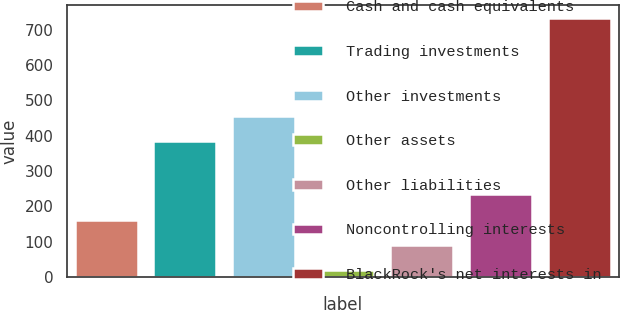Convert chart. <chart><loc_0><loc_0><loc_500><loc_500><bar_chart><fcel>Cash and cash equivalents<fcel>Trading investments<fcel>Other investments<fcel>Other assets<fcel>Other liabilities<fcel>Noncontrolling interests<fcel>BlackRock's net interests in<nl><fcel>162.4<fcel>385<fcel>456.2<fcel>20<fcel>91.2<fcel>233.6<fcel>732<nl></chart> 